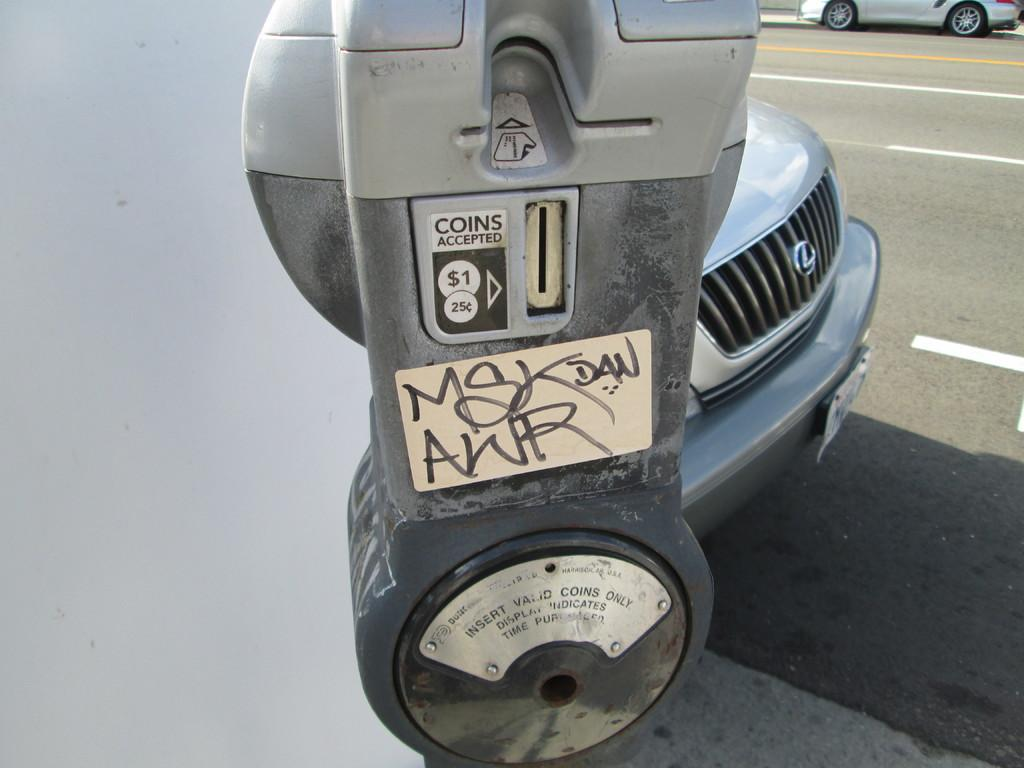Provide a one-sentence caption for the provided image. A parking meter that reads coins accepted, $1, 25 cents. 